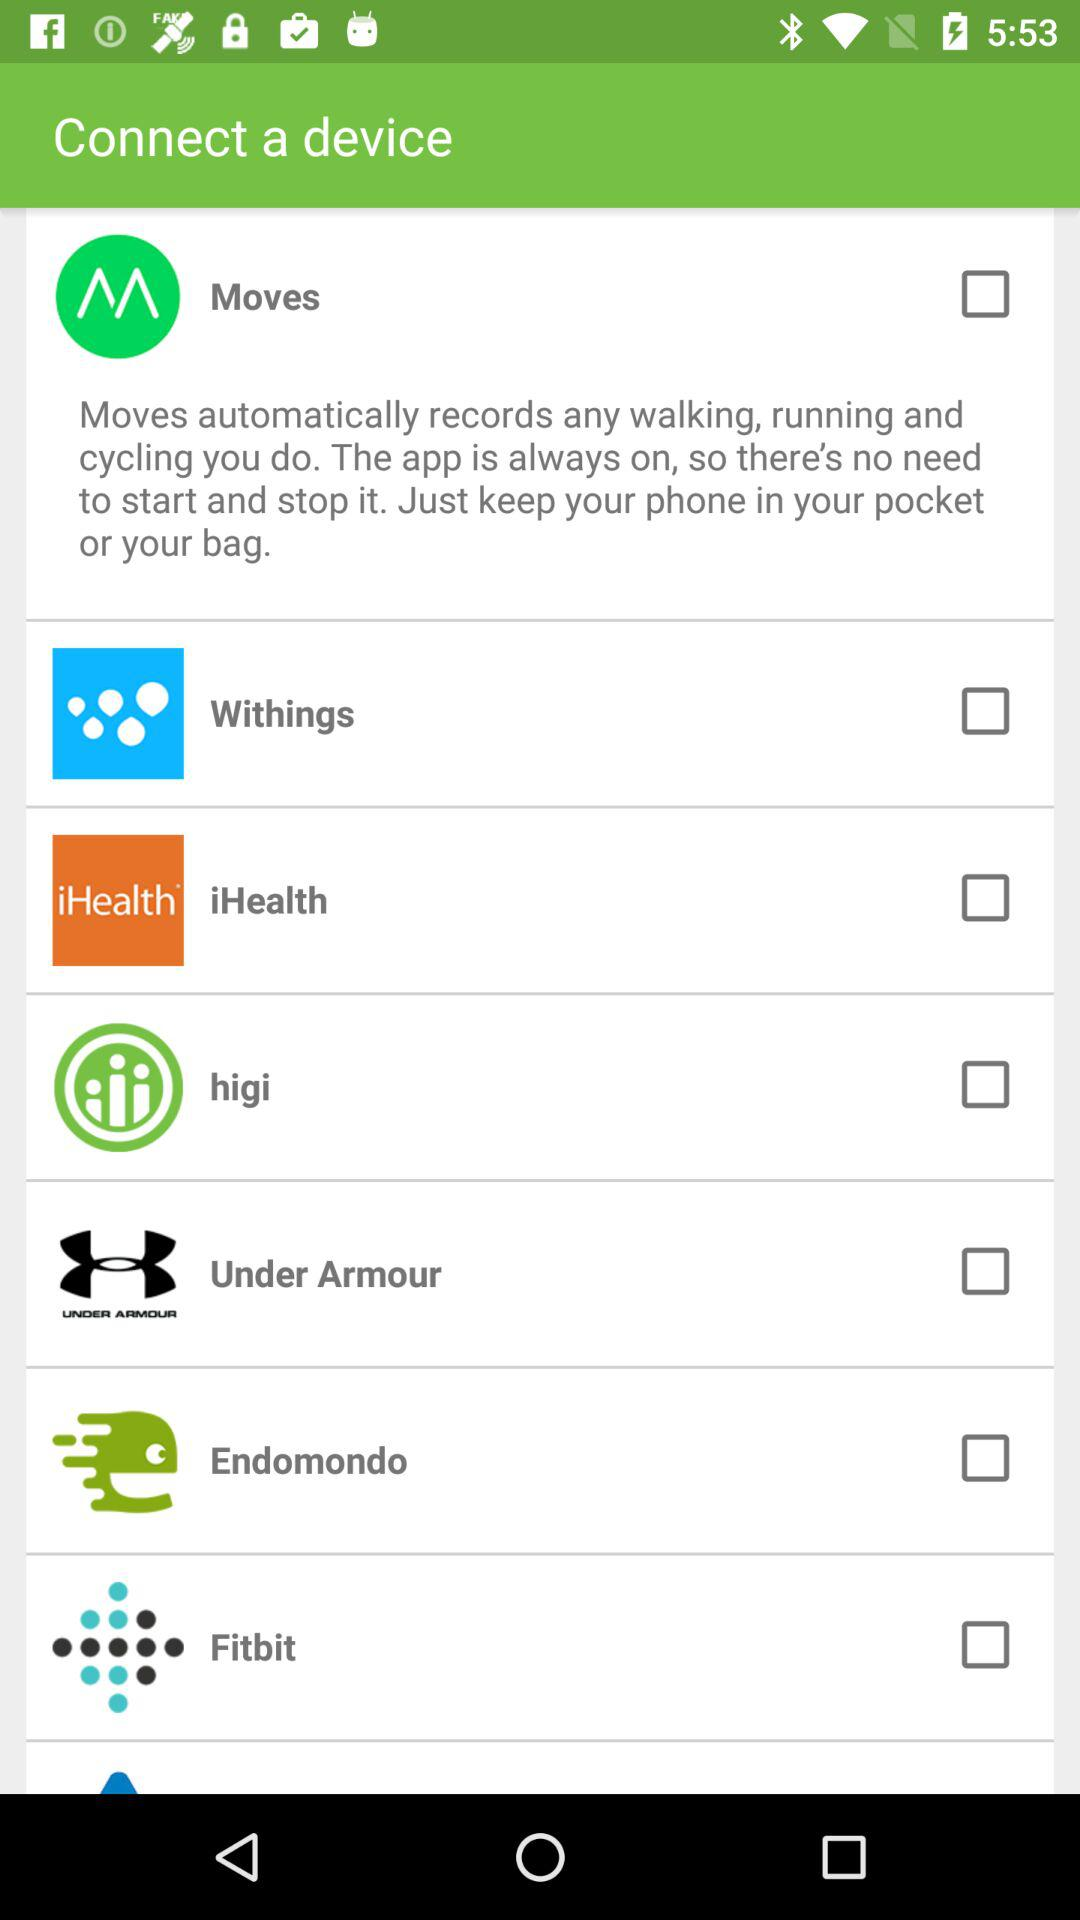What is the current status of "higi"? The current status of "higi" is "off". 